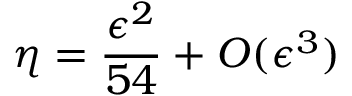Convert formula to latex. <formula><loc_0><loc_0><loc_500><loc_500>\eta = { \frac { \epsilon ^ { 2 } } { 5 4 } } + O ( \epsilon ^ { 3 } )</formula> 